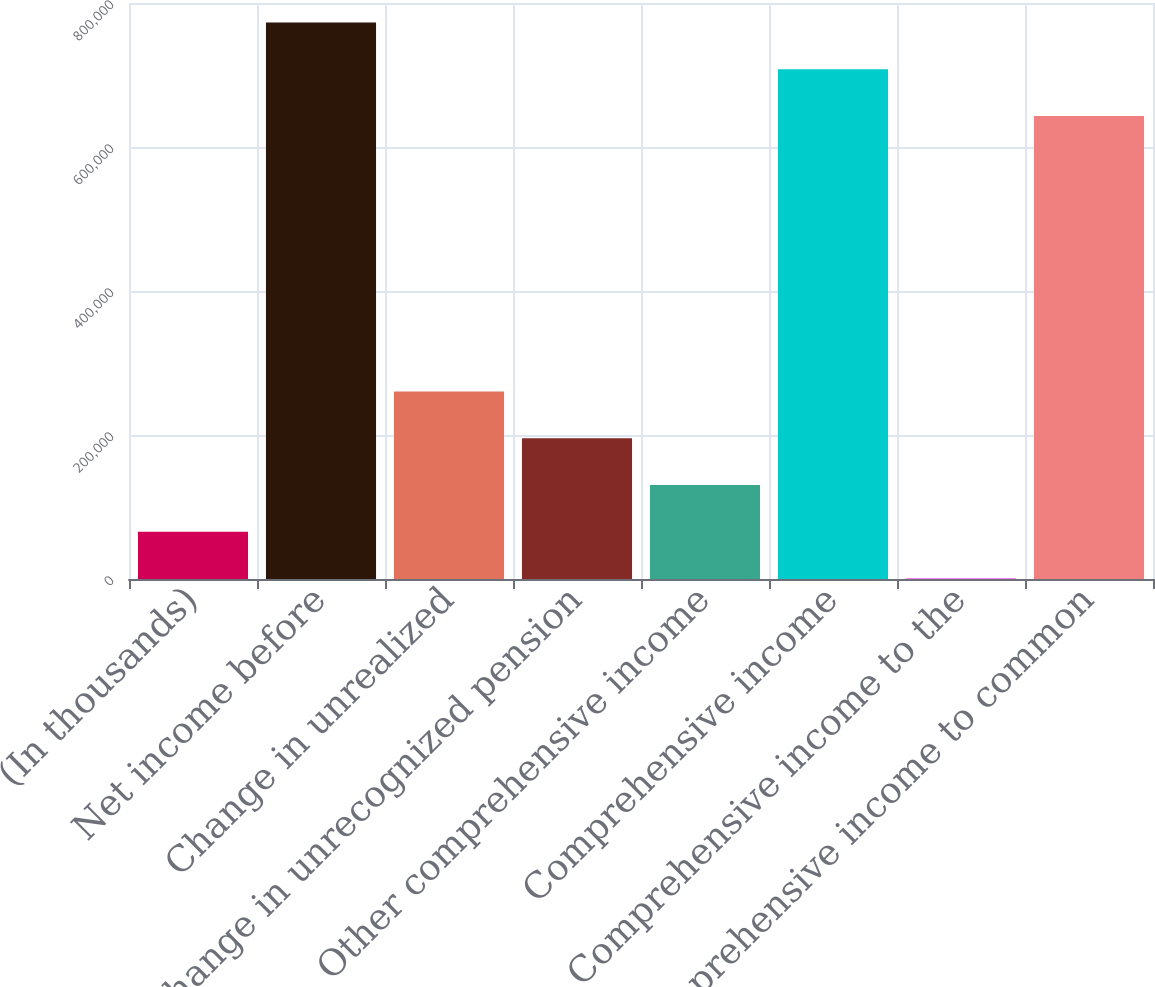<chart> <loc_0><loc_0><loc_500><loc_500><bar_chart><fcel>(In thousands)<fcel>Net income before<fcel>Change in unrealized<fcel>Change in unrecognized pension<fcel>Other comprehensive income<fcel>Comprehensive income<fcel>Comprehensive income to the<fcel>Comprehensive income to common<nl><fcel>65637.1<fcel>772813<fcel>260292<fcel>195407<fcel>130522<fcel>707928<fcel>752<fcel>643043<nl></chart> 